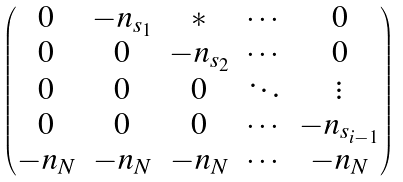<formula> <loc_0><loc_0><loc_500><loc_500>\left ( \begin{matrix} 0 & - n _ { s _ { 1 } } & \ast & \cdots & 0 \\ 0 & 0 & - n _ { s _ { 2 } } & \cdots & 0 \\ 0 & 0 & 0 & \ddots & \vdots \\ 0 & 0 & 0 & \cdots & - n _ { s _ { i - 1 } } \\ - n _ { N } & - n _ { N } & - n _ { N } & \cdots & - n _ { N } \end{matrix} \right )</formula> 